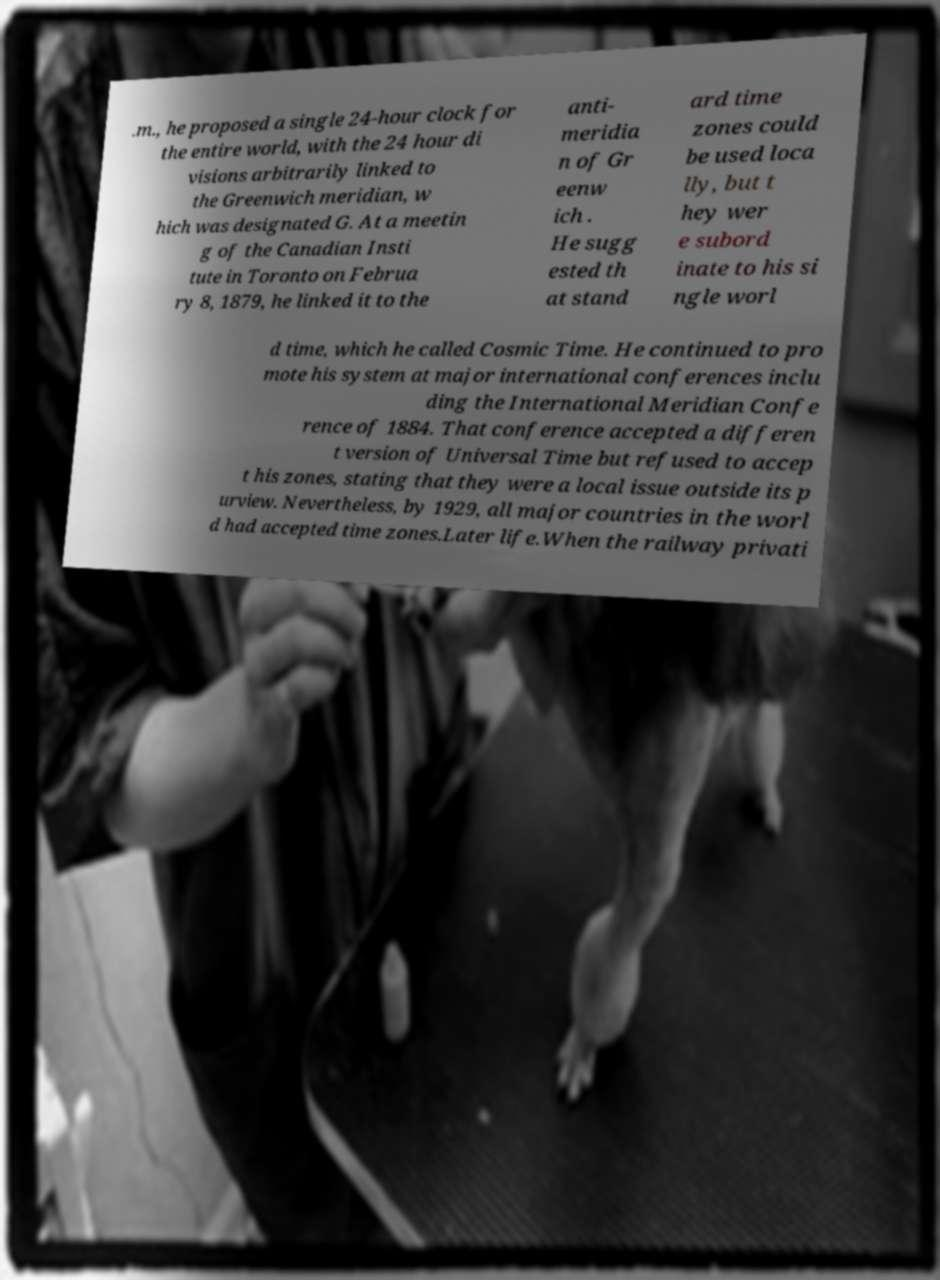For documentation purposes, I need the text within this image transcribed. Could you provide that? .m., he proposed a single 24-hour clock for the entire world, with the 24 hour di visions arbitrarily linked to the Greenwich meridian, w hich was designated G. At a meetin g of the Canadian Insti tute in Toronto on Februa ry 8, 1879, he linked it to the anti- meridia n of Gr eenw ich . He sugg ested th at stand ard time zones could be used loca lly, but t hey wer e subord inate to his si ngle worl d time, which he called Cosmic Time. He continued to pro mote his system at major international conferences inclu ding the International Meridian Confe rence of 1884. That conference accepted a differen t version of Universal Time but refused to accep t his zones, stating that they were a local issue outside its p urview. Nevertheless, by 1929, all major countries in the worl d had accepted time zones.Later life.When the railway privati 